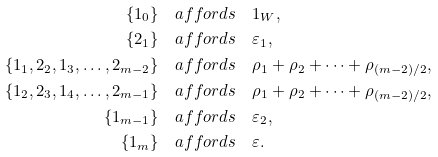Convert formula to latex. <formula><loc_0><loc_0><loc_500><loc_500>\{ 1 _ { 0 } \} & \quad a f f o r d s \quad 1 _ { W } , \\ \{ 2 _ { 1 } \} & \quad a f f o r d s \quad \varepsilon _ { 1 } , \\ \{ 1 _ { 1 } , 2 _ { 2 } , 1 _ { 3 } , \dots , 2 _ { m - 2 } \} & \quad a f f o r d s \quad \rho _ { 1 } + \rho _ { 2 } + \cdots + \rho _ { ( m - 2 ) / 2 } , \\ \{ 1 _ { 2 } , 2 _ { 3 } , 1 _ { 4 } , \dots , 2 _ { m - 1 } \} & \quad a f f o r d s \quad \rho _ { 1 } + \rho _ { 2 } + \cdots + \rho _ { ( m - 2 ) / 2 } , \\ \{ 1 _ { m - 1 } \} & \quad a f f o r d s \quad \varepsilon _ { 2 } , \\ \{ 1 _ { m } \} & \quad a f f o r d s \quad \varepsilon .</formula> 